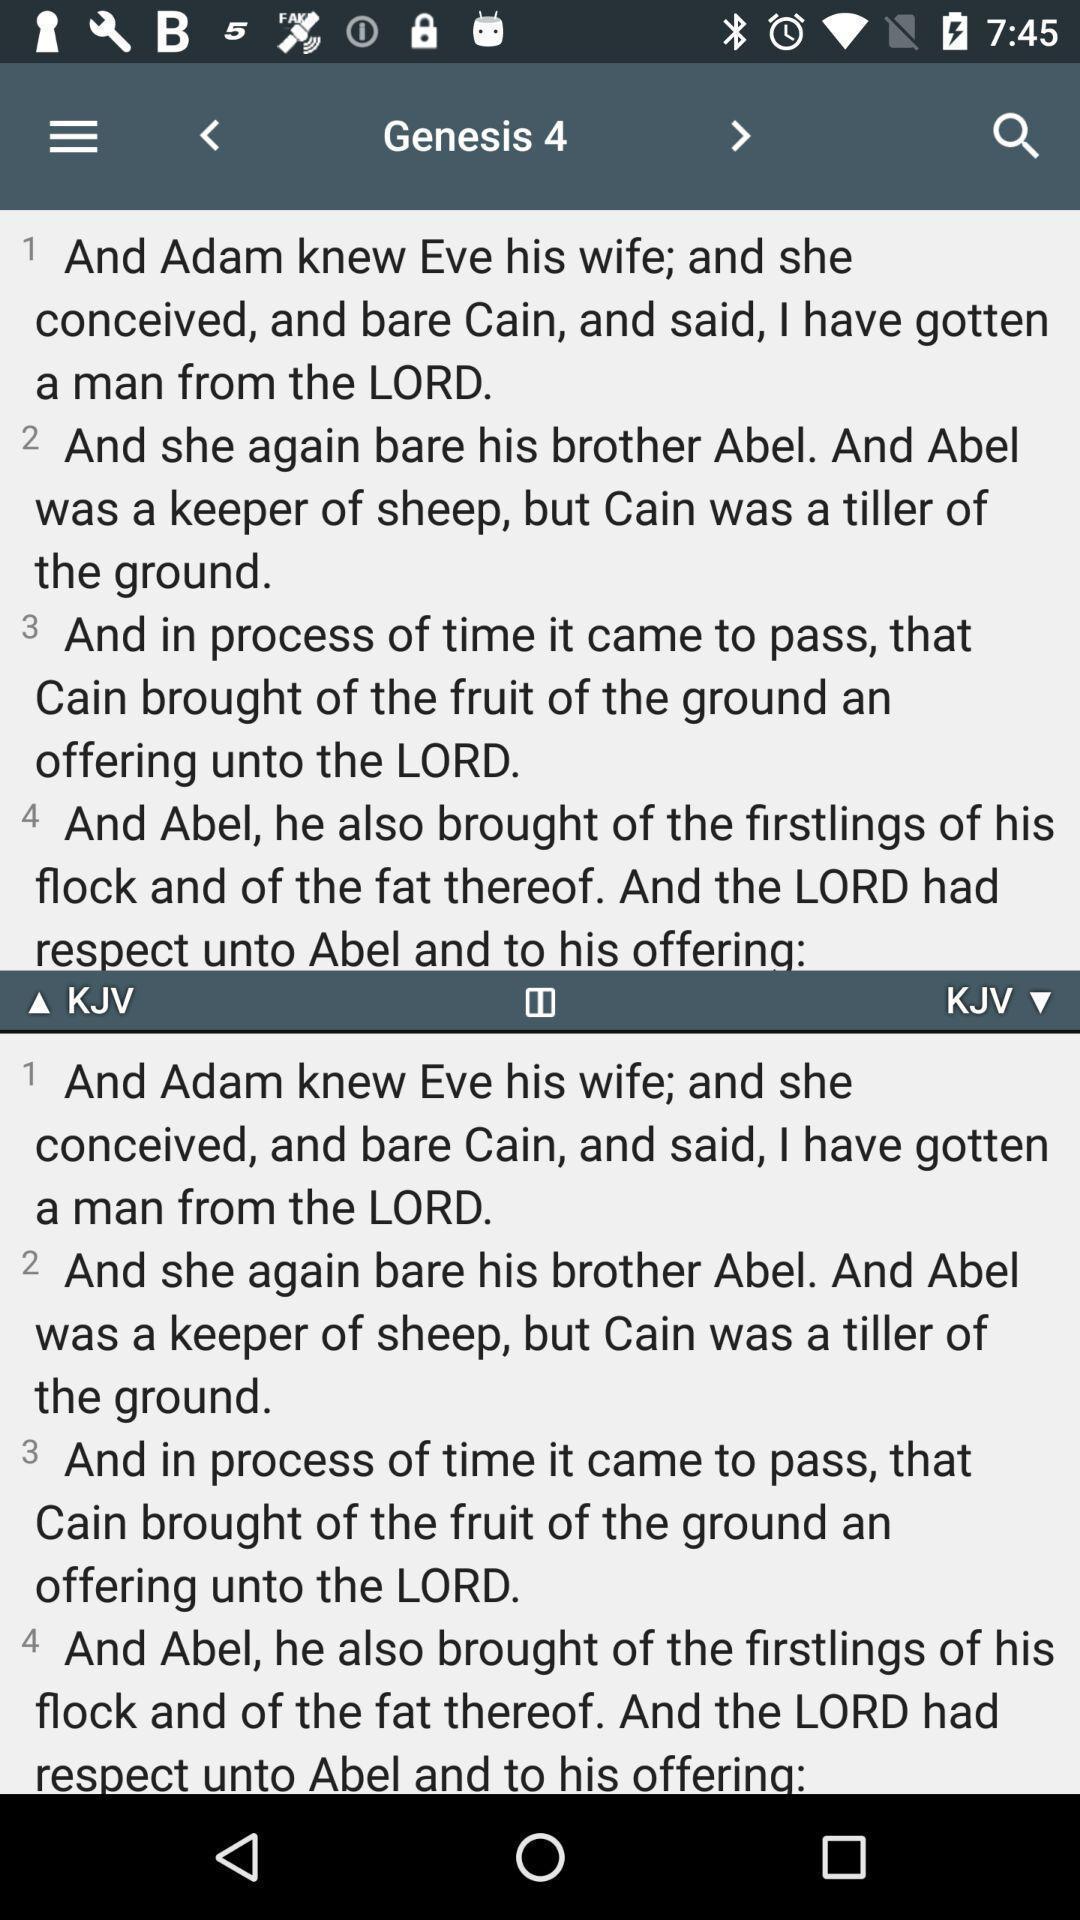Summarize the main components in this picture. Page showing information about bible. 